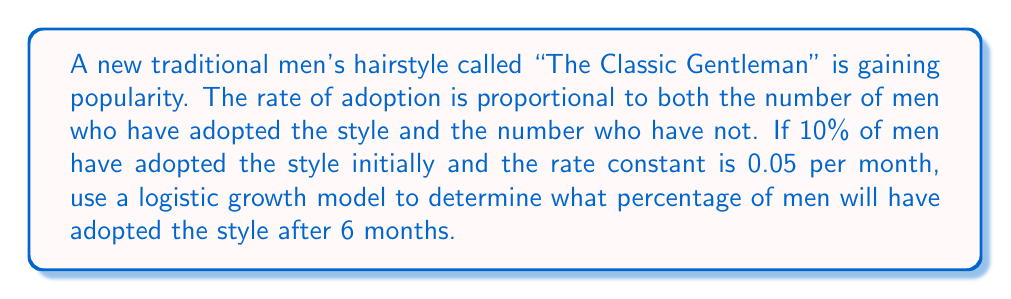Teach me how to tackle this problem. Let's approach this step-by-step using the logistic growth model:

1) Let $P(t)$ be the proportion of men who have adopted the style at time $t$ (in months).

2) The logistic growth model is given by the differential equation:

   $$\frac{dP}{dt} = kP(1-P)$$

   where $k$ is the rate constant.

3) We're given that $k = 0.05$ and the initial condition $P(0) = 0.1$ (10% initial adoption).

4) The solution to this differential equation is:

   $$P(t) = \frac{P(0)}{P(0) + (1-P(0))e^{-kt}}$$

5) Substituting our values:

   $$P(t) = \frac{0.1}{0.1 + (1-0.1)e^{-0.05t}}$$

6) We want to find $P(6)$, so let's substitute $t=6$:

   $$P(6) = \frac{0.1}{0.1 + 0.9e^{-0.05(6)}}$$

7) Calculating:
   
   $$P(6) = \frac{0.1}{0.1 + 0.9e^{-0.3}} \approx 0.1898$$

8) Converting to a percentage:

   $0.1898 \times 100\% \approx 19.0\%$

Thus, after 6 months, approximately 19.0% of men will have adopted the new hairstyle.
Answer: 19.0% 